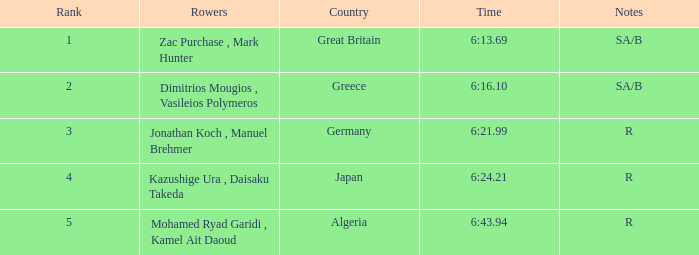What's the time of Rank 3? 6:21.99. 